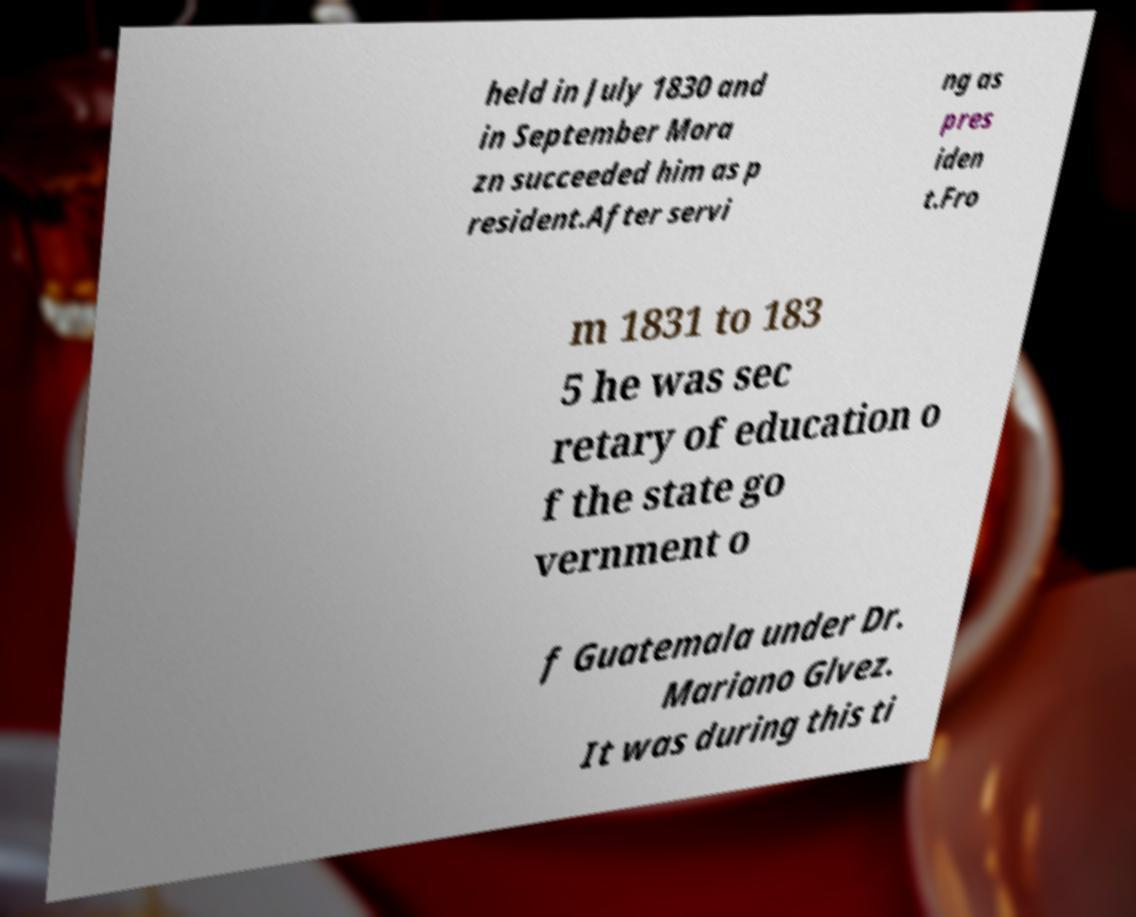What messages or text are displayed in this image? I need them in a readable, typed format. held in July 1830 and in September Mora zn succeeded him as p resident.After servi ng as pres iden t.Fro m 1831 to 183 5 he was sec retary of education o f the state go vernment o f Guatemala under Dr. Mariano Glvez. It was during this ti 